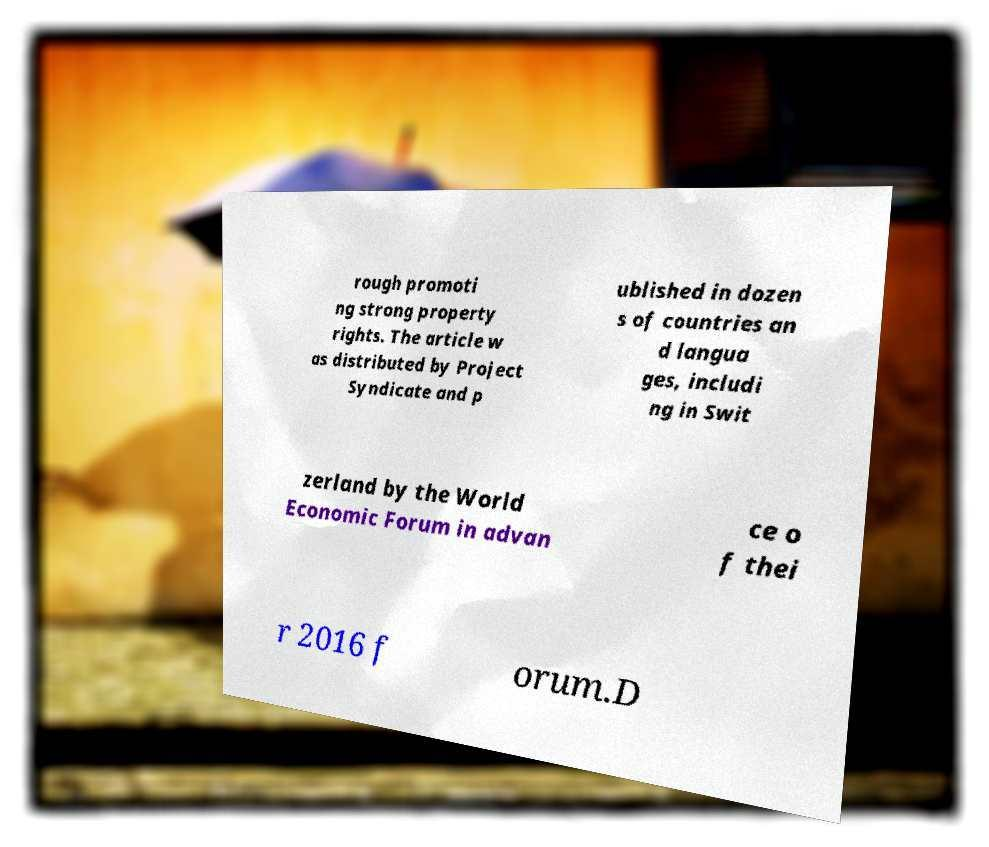For documentation purposes, I need the text within this image transcribed. Could you provide that? rough promoti ng strong property rights. The article w as distributed by Project Syndicate and p ublished in dozen s of countries an d langua ges, includi ng in Swit zerland by the World Economic Forum in advan ce o f thei r 2016 f orum.D 